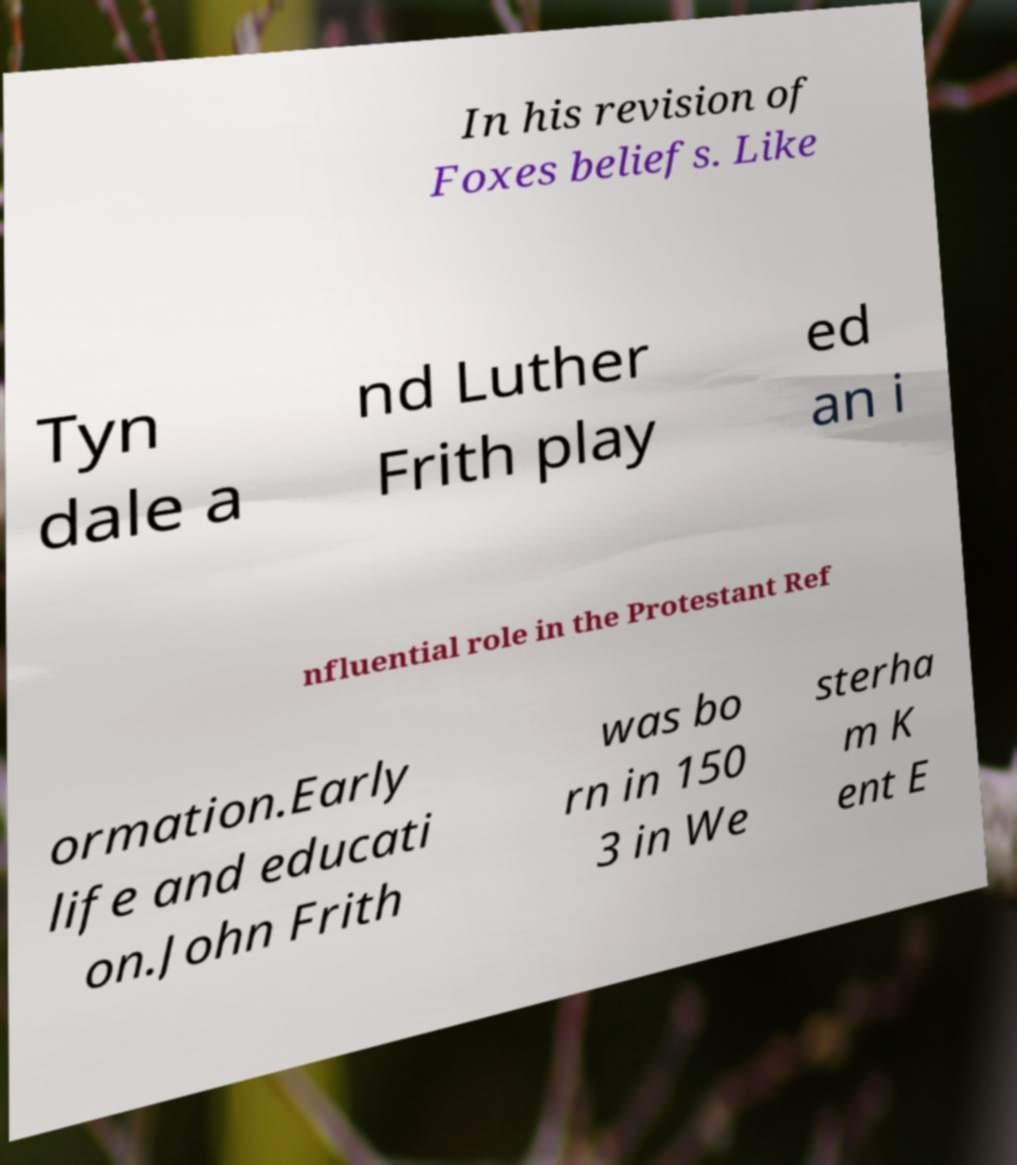Please read and relay the text visible in this image. What does it say? In his revision of Foxes beliefs. Like Tyn dale a nd Luther Frith play ed an i nfluential role in the Protestant Ref ormation.Early life and educati on.John Frith was bo rn in 150 3 in We sterha m K ent E 